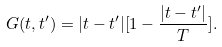<formula> <loc_0><loc_0><loc_500><loc_500>G ( t , t ^ { \prime } ) = | t - t ^ { \prime } | [ 1 - \frac { | t - t ^ { \prime } | } { T } ] .</formula> 